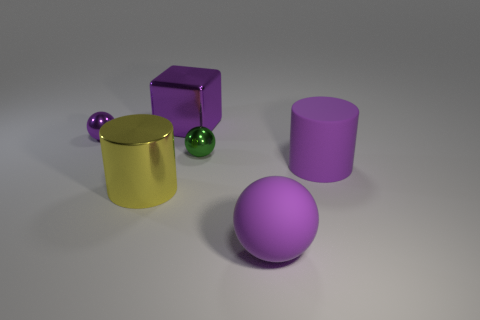Is the large purple object that is on the right side of the large rubber ball made of the same material as the big yellow object?
Your answer should be very brief. No. The big object that is left of the big purple sphere and behind the large yellow metallic cylinder has what shape?
Your response must be concise. Cube. Is there a cube on the right side of the purple matte object left of the big rubber cylinder?
Make the answer very short. No. What number of other things are the same material as the large purple cube?
Your answer should be compact. 3. There is a purple object that is in front of the shiny cylinder; is its shape the same as the small object to the left of the tiny green sphere?
Make the answer very short. Yes. Is the material of the yellow object the same as the purple cylinder?
Your answer should be very brief. No. How big is the matte thing that is behind the large yellow object that is left of the purple matte object on the left side of the large purple cylinder?
Offer a terse response. Large. What number of other objects are the same color as the large shiny cylinder?
Provide a succinct answer. 0. There is a purple metallic object that is the same size as the metallic cylinder; what shape is it?
Give a very brief answer. Cube. How many small objects are shiny objects or green things?
Your answer should be very brief. 2. 